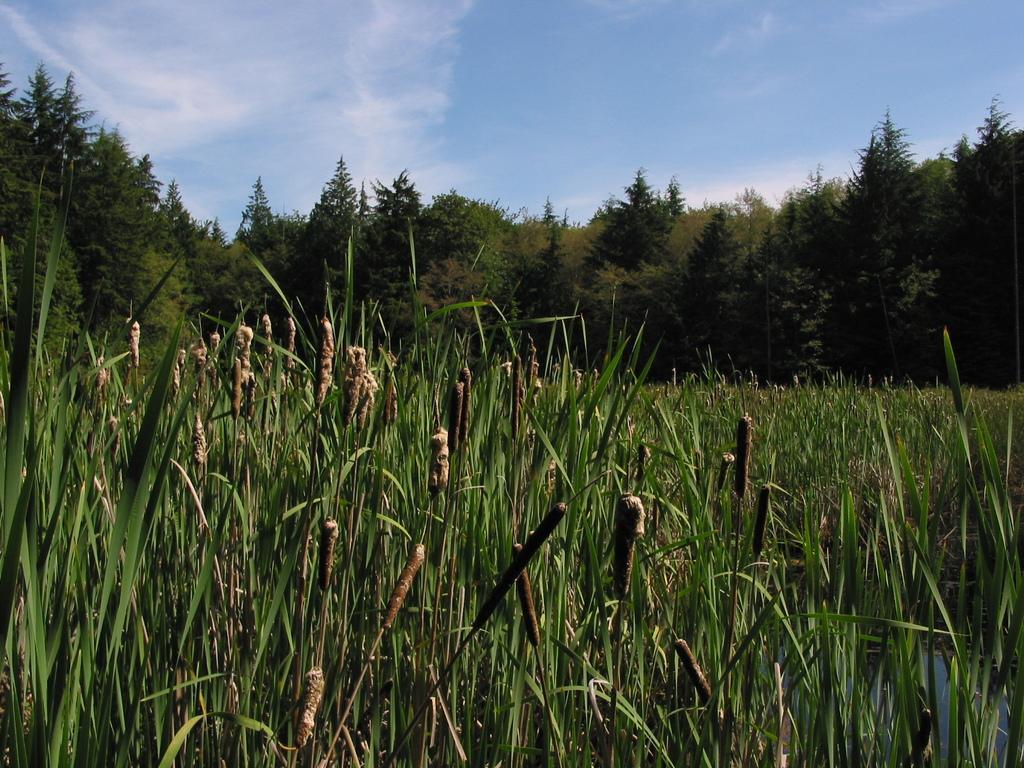Could you give a brief overview of what you see in this image? In the foreground of this image, there is grass. In the background, there are trees, sky and the cloud. 